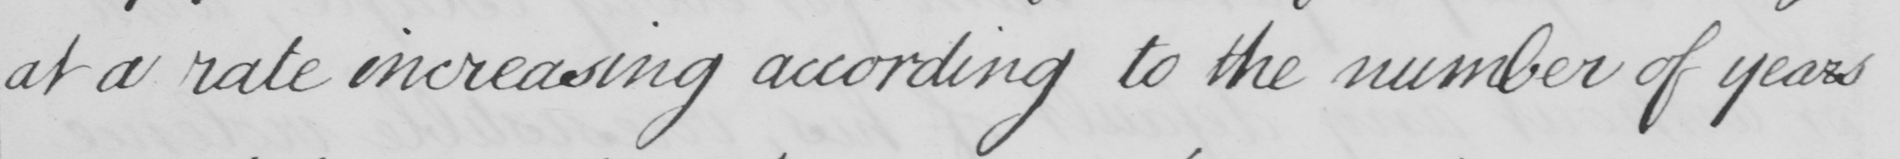Please transcribe the handwritten text in this image. at a rate increasing according to the number of years 